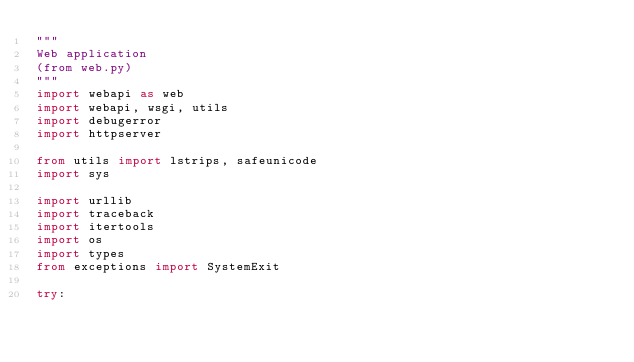Convert code to text. <code><loc_0><loc_0><loc_500><loc_500><_Python_>"""
Web application
(from web.py)
"""
import webapi as web
import webapi, wsgi, utils
import debugerror
import httpserver

from utils import lstrips, safeunicode
import sys

import urllib
import traceback
import itertools
import os
import types
from exceptions import SystemExit

try:</code> 